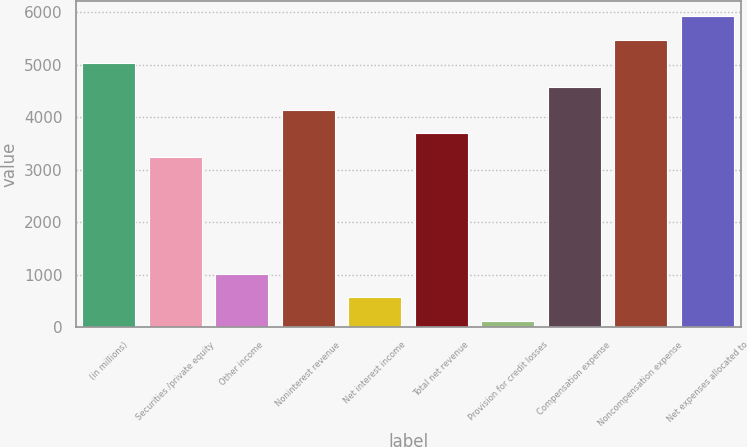Convert chart. <chart><loc_0><loc_0><loc_500><loc_500><bar_chart><fcel>(in millions)<fcel>Securities /private equity<fcel>Other income<fcel>Noninterest revenue<fcel>Net interest income<fcel>Total net revenue<fcel>Provision for credit losses<fcel>Compensation expense<fcel>Noncompensation expense<fcel>Net expenses allocated to<nl><fcel>5025.6<fcel>3243.2<fcel>1015.2<fcel>4134.4<fcel>569.6<fcel>3688.8<fcel>124<fcel>4580<fcel>5471.2<fcel>5916.8<nl></chart> 